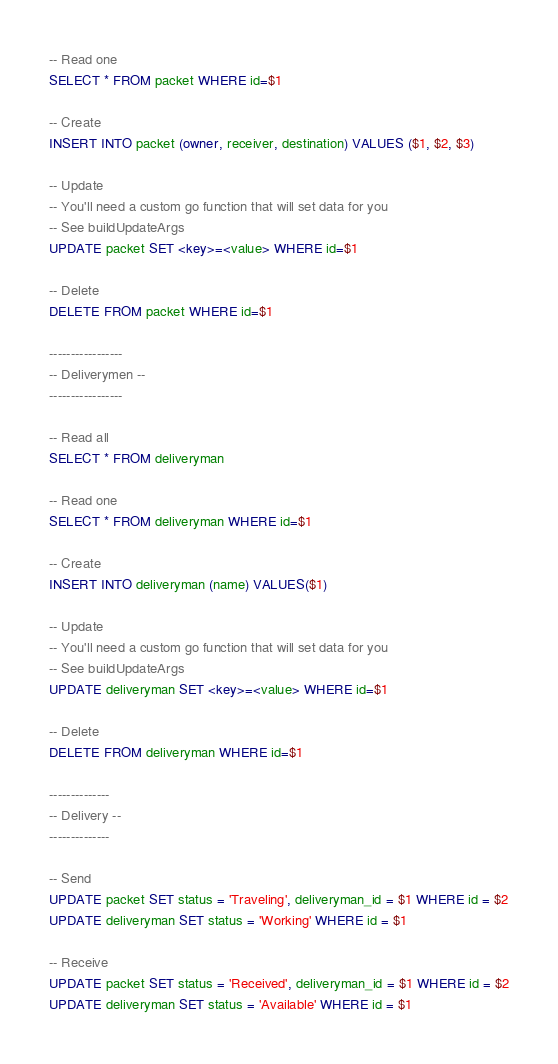<code> <loc_0><loc_0><loc_500><loc_500><_SQL_>-- Read one
SELECT * FROM packet WHERE id=$1

-- Create
INSERT INTO packet (owner, receiver, destination) VALUES ($1, $2, $3)

-- Update
-- You'll need a custom go function that will set data for you
-- See buildUpdateArgs
UPDATE packet SET <key>=<value> WHERE id=$1

-- Delete
DELETE FROM packet WHERE id=$1

-----------------
-- Deliverymen --
-----------------

-- Read all
SELECT * FROM deliveryman

-- Read one
SELECT * FROM deliveryman WHERE id=$1

-- Create
INSERT INTO deliveryman (name) VALUES($1)

-- Update
-- You'll need a custom go function that will set data for you
-- See buildUpdateArgs
UPDATE deliveryman SET <key>=<value> WHERE id=$1

-- Delete
DELETE FROM deliveryman WHERE id=$1

--------------
-- Delivery --
--------------

-- Send
UPDATE packet SET status = 'Traveling', deliveryman_id = $1 WHERE id = $2
UPDATE deliveryman SET status = 'Working' WHERE id = $1

-- Receive
UPDATE packet SET status = 'Received', deliveryman_id = $1 WHERE id = $2
UPDATE deliveryman SET status = 'Available' WHERE id = $1</code> 